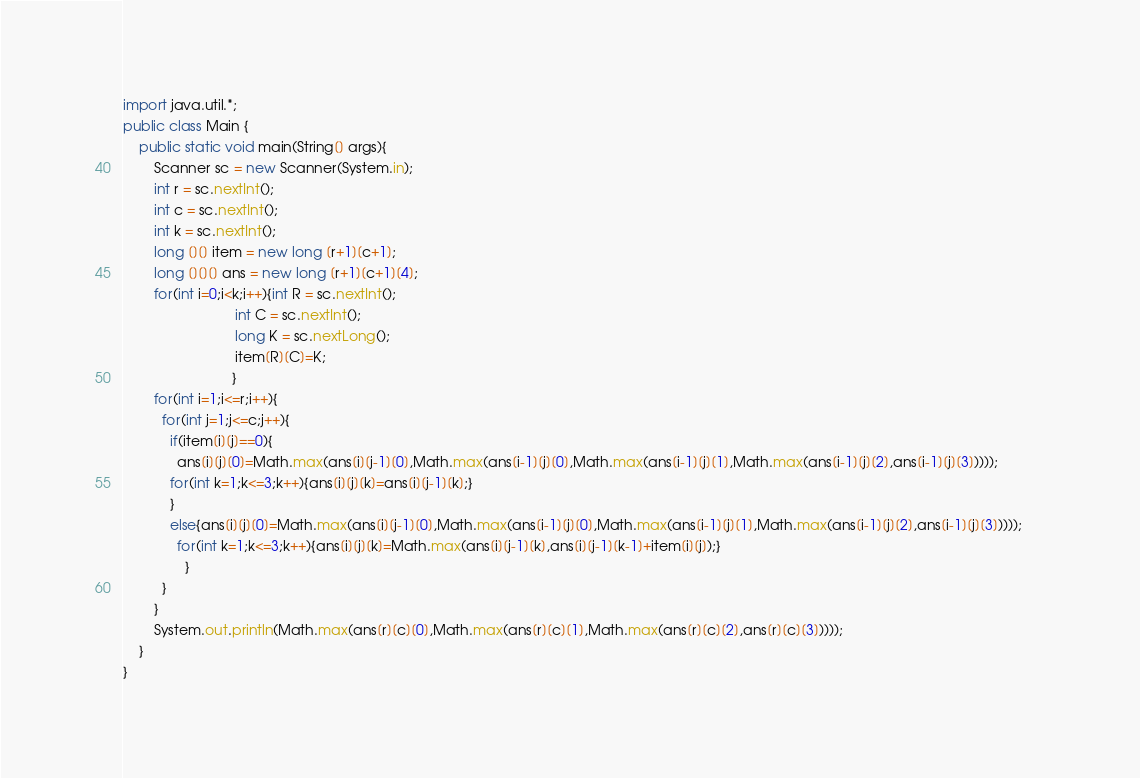Convert code to text. <code><loc_0><loc_0><loc_500><loc_500><_Java_>import java.util.*;
public class Main {
	public static void main(String[] args){
		Scanner sc = new Scanner(System.in);
		int r = sc.nextInt();
        int c = sc.nextInt();
        int k = sc.nextInt();
		long [][] item = new long [r+1][c+1];
        long [][][] ans = new long [r+1][c+1][4];
        for(int i=0;i<k;i++){int R = sc.nextInt();
                             int C = sc.nextInt();
                             long K = sc.nextLong();
                             item[R][C]=K;
                            }		
        for(int i=1;i<=r;i++){                              
          for(int j=1;j<=c;j++){                               
            if(item[i][j]==0){                                
              ans[i][j][0]=Math.max(ans[i][j-1][0],Math.max(ans[i-1][j][0],Math.max(ans[i-1][j][1],Math.max(ans[i-1][j][2],ans[i-1][j][3]))));            
            for(int k=1;k<=3;k++){ans[i][j][k]=ans[i][j-1][k];}
            }
            else{ans[i][j][0]=Math.max(ans[i][j-1][0],Math.max(ans[i-1][j][0],Math.max(ans[i-1][j][1],Math.max(ans[i-1][j][2],ans[i-1][j][3]))));
              for(int k=1;k<=3;k++){ans[i][j][k]=Math.max(ans[i][j-1][k],ans[i][j-1][k-1]+item[i][j]);}           
                }                                  
          } 
        }      
		System.out.println(Math.max(ans[r][c][0],Math.max(ans[r][c][1],Math.max(ans[r][c][2],ans[r][c][3]))));
	}
}
</code> 